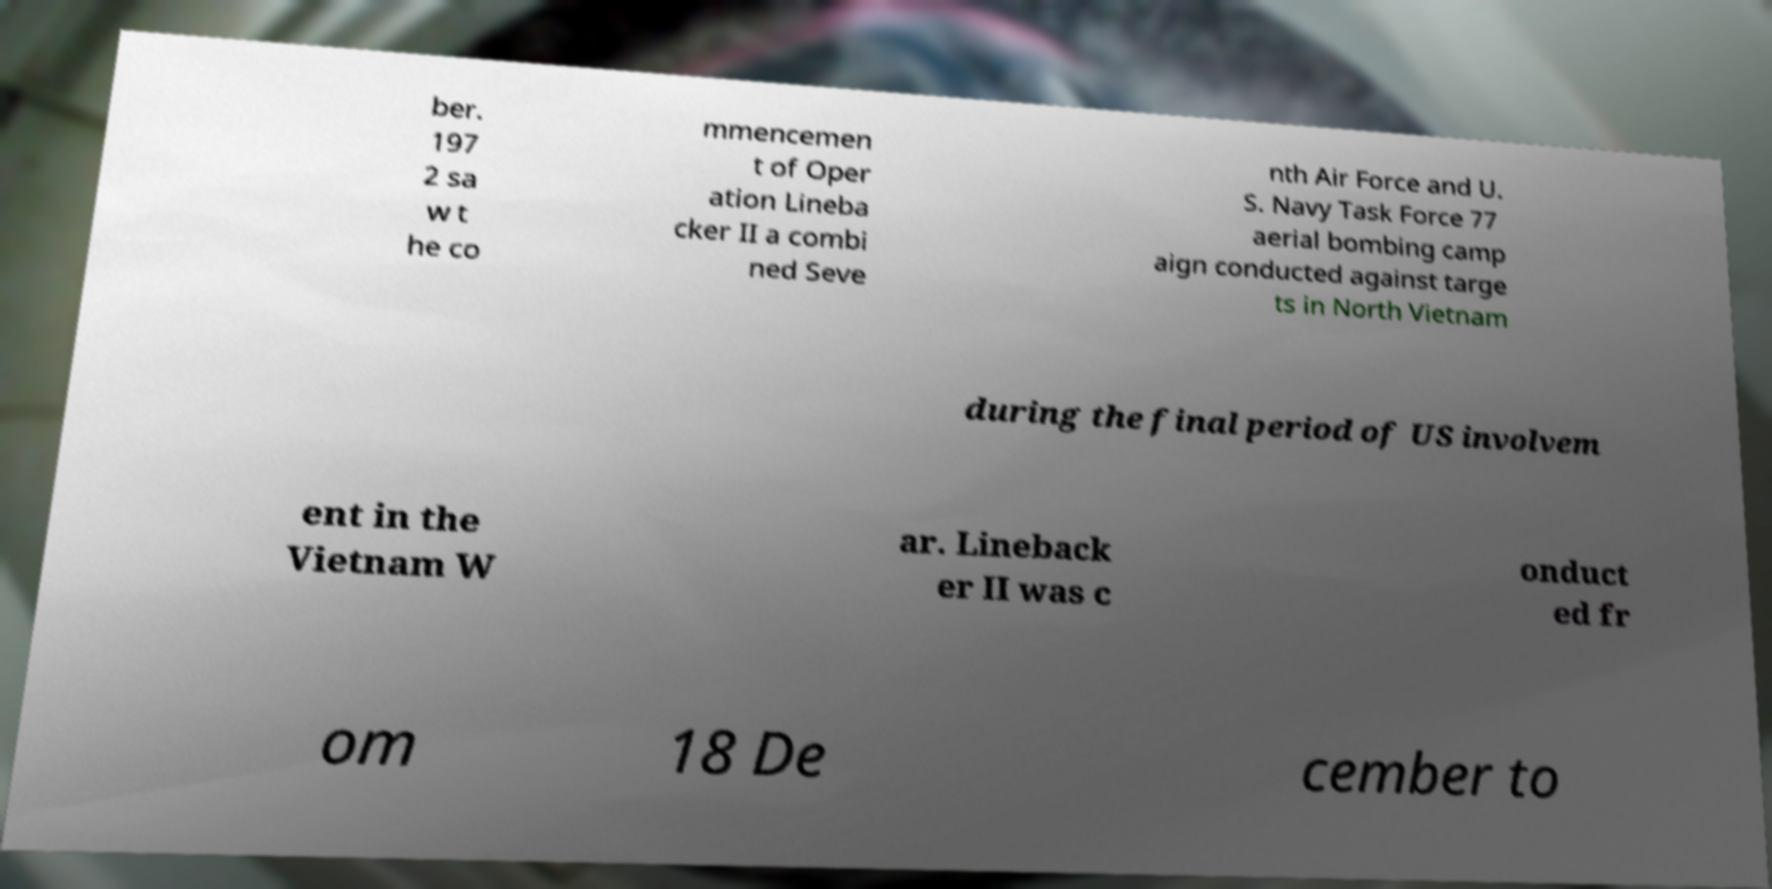Could you extract and type out the text from this image? ber. 197 2 sa w t he co mmencemen t of Oper ation Lineba cker II a combi ned Seve nth Air Force and U. S. Navy Task Force 77 aerial bombing camp aign conducted against targe ts in North Vietnam during the final period of US involvem ent in the Vietnam W ar. Lineback er II was c onduct ed fr om 18 De cember to 